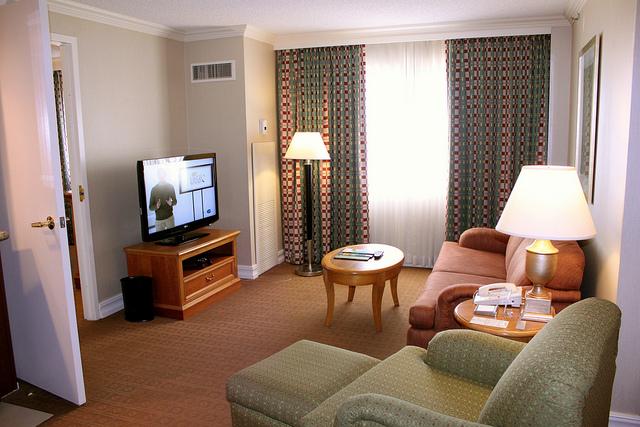What is the black item on the floor next to the television?
Short answer required. Trash can. Does the photo depict a daytime or nighttime scene?
Keep it brief. Daytime. What room is this?
Concise answer only. Living room. 